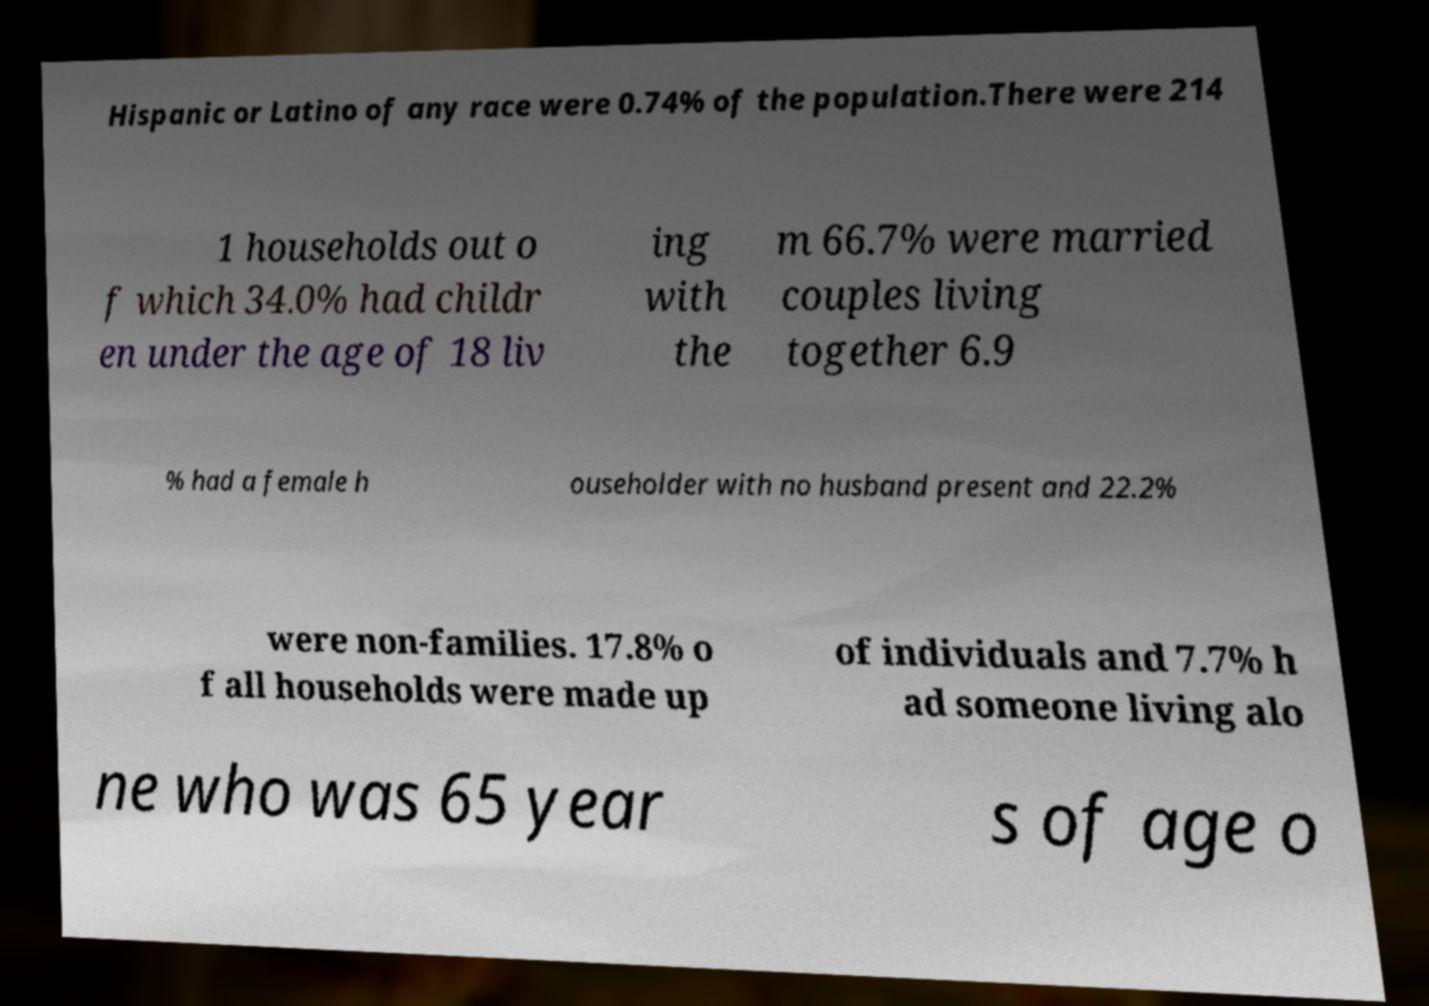Can you read and provide the text displayed in the image?This photo seems to have some interesting text. Can you extract and type it out for me? Hispanic or Latino of any race were 0.74% of the population.There were 214 1 households out o f which 34.0% had childr en under the age of 18 liv ing with the m 66.7% were married couples living together 6.9 % had a female h ouseholder with no husband present and 22.2% were non-families. 17.8% o f all households were made up of individuals and 7.7% h ad someone living alo ne who was 65 year s of age o 